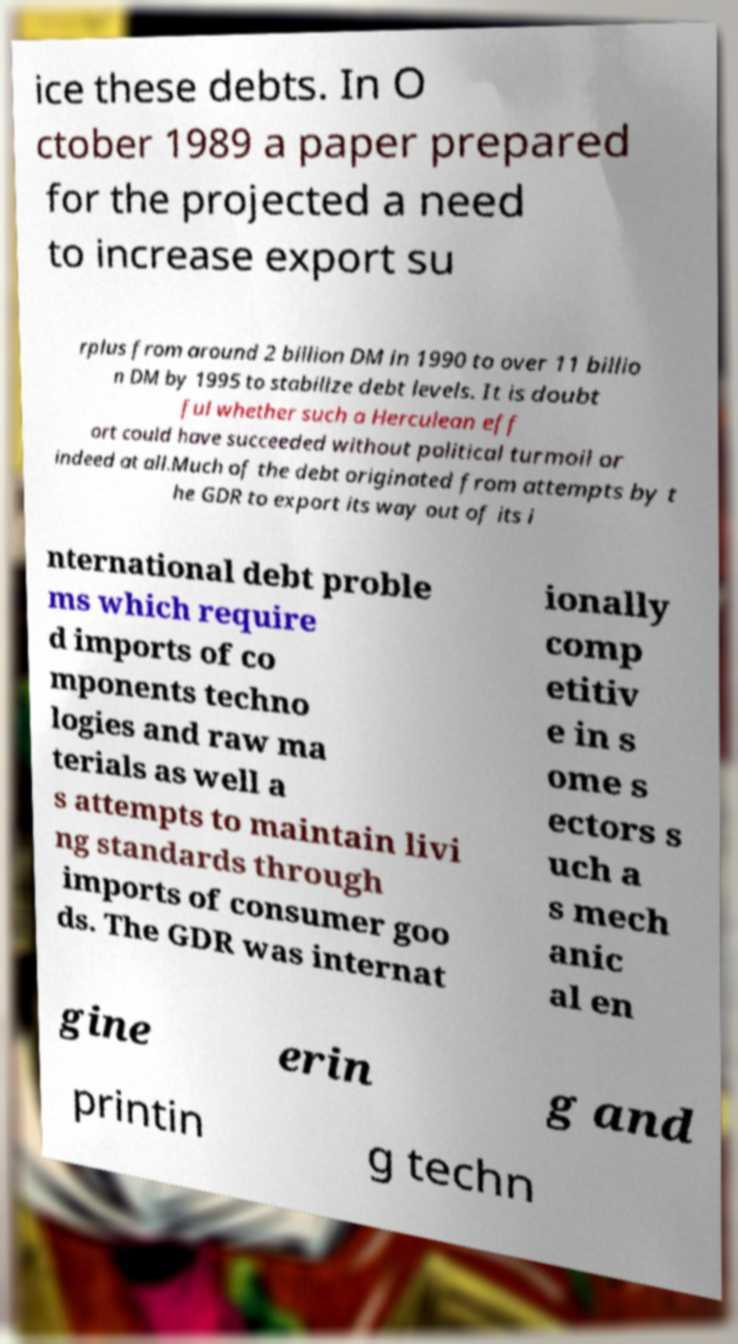Could you assist in decoding the text presented in this image and type it out clearly? ice these debts. In O ctober 1989 a paper prepared for the projected a need to increase export su rplus from around 2 billion DM in 1990 to over 11 billio n DM by 1995 to stabilize debt levels. It is doubt ful whether such a Herculean eff ort could have succeeded without political turmoil or indeed at all.Much of the debt originated from attempts by t he GDR to export its way out of its i nternational debt proble ms which require d imports of co mponents techno logies and raw ma terials as well a s attempts to maintain livi ng standards through imports of consumer goo ds. The GDR was internat ionally comp etitiv e in s ome s ectors s uch a s mech anic al en gine erin g and printin g techn 